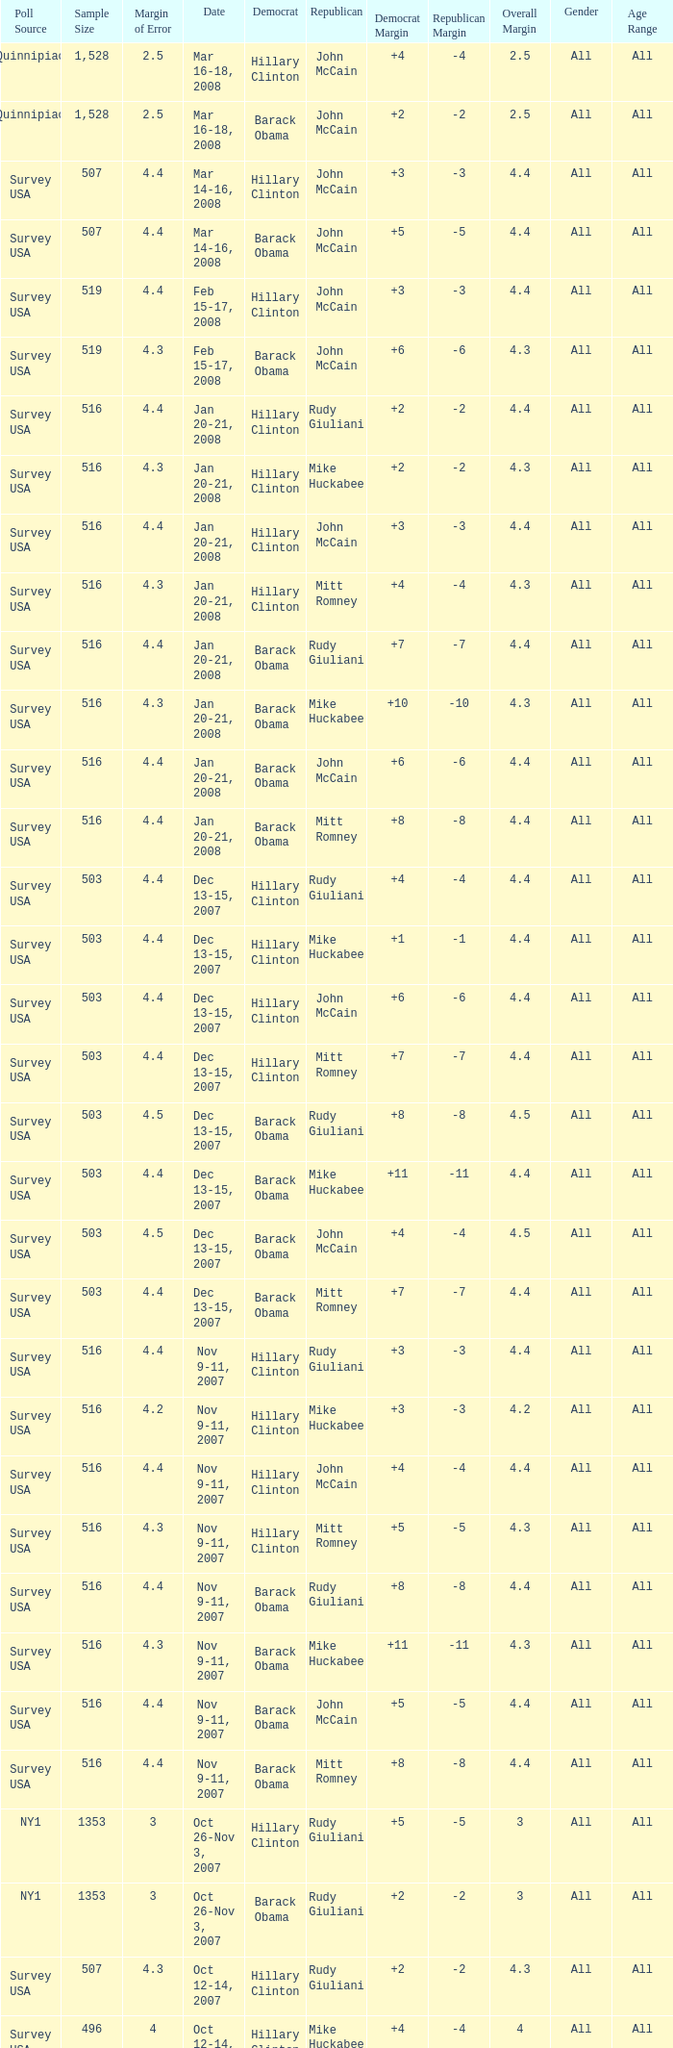Could you help me parse every detail presented in this table? {'header': ['Poll Source', 'Sample Size', 'Margin of Error', 'Date', 'Democrat', 'Republican', 'Democrat Margin', 'Republican Margin', 'Overall Margin', 'Gender', 'Age Range'], 'rows': [['Quinnipiac', '1,528', '2.5', 'Mar 16-18, 2008', 'Hillary Clinton', 'John McCain', '+4', '-4', '2.5', 'All', 'All'], ['Quinnipiac', '1,528', '2.5', 'Mar 16-18, 2008', 'Barack Obama', 'John McCain', '+2', '-2', '2.5', 'All', 'All'], ['Survey USA', '507', '4.4', 'Mar 14-16, 2008', 'Hillary Clinton', 'John McCain', '+3', '-3', '4.4', 'All', 'All'], ['Survey USA', '507', '4.4', 'Mar 14-16, 2008', 'Barack Obama', 'John McCain', '+5', '-5', '4.4', 'All', 'All'], ['Survey USA', '519', '4.4', 'Feb 15-17, 2008', 'Hillary Clinton', 'John McCain', '+3', '-3', '4.4', 'All', 'All'], ['Survey USA', '519', '4.3', 'Feb 15-17, 2008', 'Barack Obama', 'John McCain', '+6', '-6', '4.3', 'All', 'All'], ['Survey USA', '516', '4.4', 'Jan 20-21, 2008', 'Hillary Clinton', 'Rudy Giuliani', '+2', '-2', '4.4', 'All', 'All'], ['Survey USA', '516', '4.3', 'Jan 20-21, 2008', 'Hillary Clinton', 'Mike Huckabee', '+2', '-2', '4.3', 'All', 'All'], ['Survey USA', '516', '4.4', 'Jan 20-21, 2008', 'Hillary Clinton', 'John McCain', '+3', '-3', '4.4', 'All', 'All'], ['Survey USA', '516', '4.3', 'Jan 20-21, 2008', 'Hillary Clinton', 'Mitt Romney', '+4', '-4', '4.3', 'All', 'All'], ['Survey USA', '516', '4.4', 'Jan 20-21, 2008', 'Barack Obama', 'Rudy Giuliani', '+7', '-7', '4.4', 'All', 'All'], ['Survey USA', '516', '4.3', 'Jan 20-21, 2008', 'Barack Obama', 'Mike Huckabee', '+10', '-10', '4.3', 'All', 'All'], ['Survey USA', '516', '4.4', 'Jan 20-21, 2008', 'Barack Obama', 'John McCain', '+6', '-6', '4.4', 'All', 'All'], ['Survey USA', '516', '4.4', 'Jan 20-21, 2008', 'Barack Obama', 'Mitt Romney', '+8', '-8', '4.4', 'All', 'All'], ['Survey USA', '503', '4.4', 'Dec 13-15, 2007', 'Hillary Clinton', 'Rudy Giuliani', '+4', '-4', '4.4', 'All', 'All'], ['Survey USA', '503', '4.4', 'Dec 13-15, 2007', 'Hillary Clinton', 'Mike Huckabee', '+1', '-1', '4.4', 'All', 'All'], ['Survey USA', '503', '4.4', 'Dec 13-15, 2007', 'Hillary Clinton', 'John McCain', '+6', '-6', '4.4', 'All', 'All'], ['Survey USA', '503', '4.4', 'Dec 13-15, 2007', 'Hillary Clinton', 'Mitt Romney', '+7', '-7', '4.4', 'All', 'All'], ['Survey USA', '503', '4.5', 'Dec 13-15, 2007', 'Barack Obama', 'Rudy Giuliani', '+8', '-8', '4.5', 'All', 'All'], ['Survey USA', '503', '4.4', 'Dec 13-15, 2007', 'Barack Obama', 'Mike Huckabee', '+11', '-11', '4.4', 'All', 'All'], ['Survey USA', '503', '4.5', 'Dec 13-15, 2007', 'Barack Obama', 'John McCain', '+4', '-4', '4.5', 'All', 'All'], ['Survey USA', '503', '4.4', 'Dec 13-15, 2007', 'Barack Obama', 'Mitt Romney', '+7', '-7', '4.4', 'All', 'All'], ['Survey USA', '516', '4.4', 'Nov 9-11, 2007', 'Hillary Clinton', 'Rudy Giuliani', '+3', '-3', '4.4', 'All', 'All'], ['Survey USA', '516', '4.2', 'Nov 9-11, 2007', 'Hillary Clinton', 'Mike Huckabee', '+3', '-3', '4.2', 'All', 'All'], ['Survey USA', '516', '4.4', 'Nov 9-11, 2007', 'Hillary Clinton', 'John McCain', '+4', '-4', '4.4', 'All', 'All'], ['Survey USA', '516', '4.3', 'Nov 9-11, 2007', 'Hillary Clinton', 'Mitt Romney', '+5', '-5', '4.3', 'All', 'All'], ['Survey USA', '516', '4.4', 'Nov 9-11, 2007', 'Barack Obama', 'Rudy Giuliani', '+8', '-8', '4.4', 'All', 'All'], ['Survey USA', '516', '4.3', 'Nov 9-11, 2007', 'Barack Obama', 'Mike Huckabee', '+11', '-11', '4.3', 'All', 'All'], ['Survey USA', '516', '4.4', 'Nov 9-11, 2007', 'Barack Obama', 'John McCain', '+5', '-5', '4.4', 'All', 'All'], ['Survey USA', '516', '4.4', 'Nov 9-11, 2007', 'Barack Obama', 'Mitt Romney', '+8', '-8', '4.4', 'All', 'All'], ['NY1', '1353', '3', 'Oct 26-Nov 3, 2007', 'Hillary Clinton', 'Rudy Giuliani', '+5', '-5', '3', 'All', 'All'], ['NY1', '1353', '3', 'Oct 26-Nov 3, 2007', 'Barack Obama', 'Rudy Giuliani', '+2', '-2', '3', 'All', 'All'], ['Survey USA', '507', '4.3', 'Oct 12-14, 2007', 'Hillary Clinton', 'Rudy Giuliani', '+2', '-2', '4.3', 'All', 'All'], ['Survey USA', '496', '4', 'Oct 12-14, 2007', 'Hillary Clinton', 'Mike Huckabee', '+4', '-4', '4', 'All', 'All'], ['Survey USA', '493', '4.2', 'Oct 12-14, 2007', 'Hillary Clinton', 'John McCain', '+3', '-3', '4.2', 'All', 'All'], ['Survey USA', '482', '4.1', 'Oct 12-14, 2007', 'Hillary Clinton', 'Ron Paul', '+1', '-1', '4.1', 'All', 'All'], ['Survey USA', '502', '4.1', 'Oct 12-14, 2007', 'Hillary Clinton', 'Mitt Romney', '+4', '-4', '4.1', 'All', 'All'], ['Survey USA', '505', '4.1', 'Oct 12-14, 2007', 'Hillary Clinton', 'Fred Thompson', '+1', '-1', '4.1', 'All', 'All'], ['Quinnipiac', '1063', '3', 'Oct 9-15, 2007', 'Hillary Clinton', 'Rudy Giuliani', '+6', '-6', '3', 'All', 'All']]} Which Democrat was selected in the poll with a sample size smaller than 516 where the Republican chosen was Ron Paul? Hillary Clinton. 